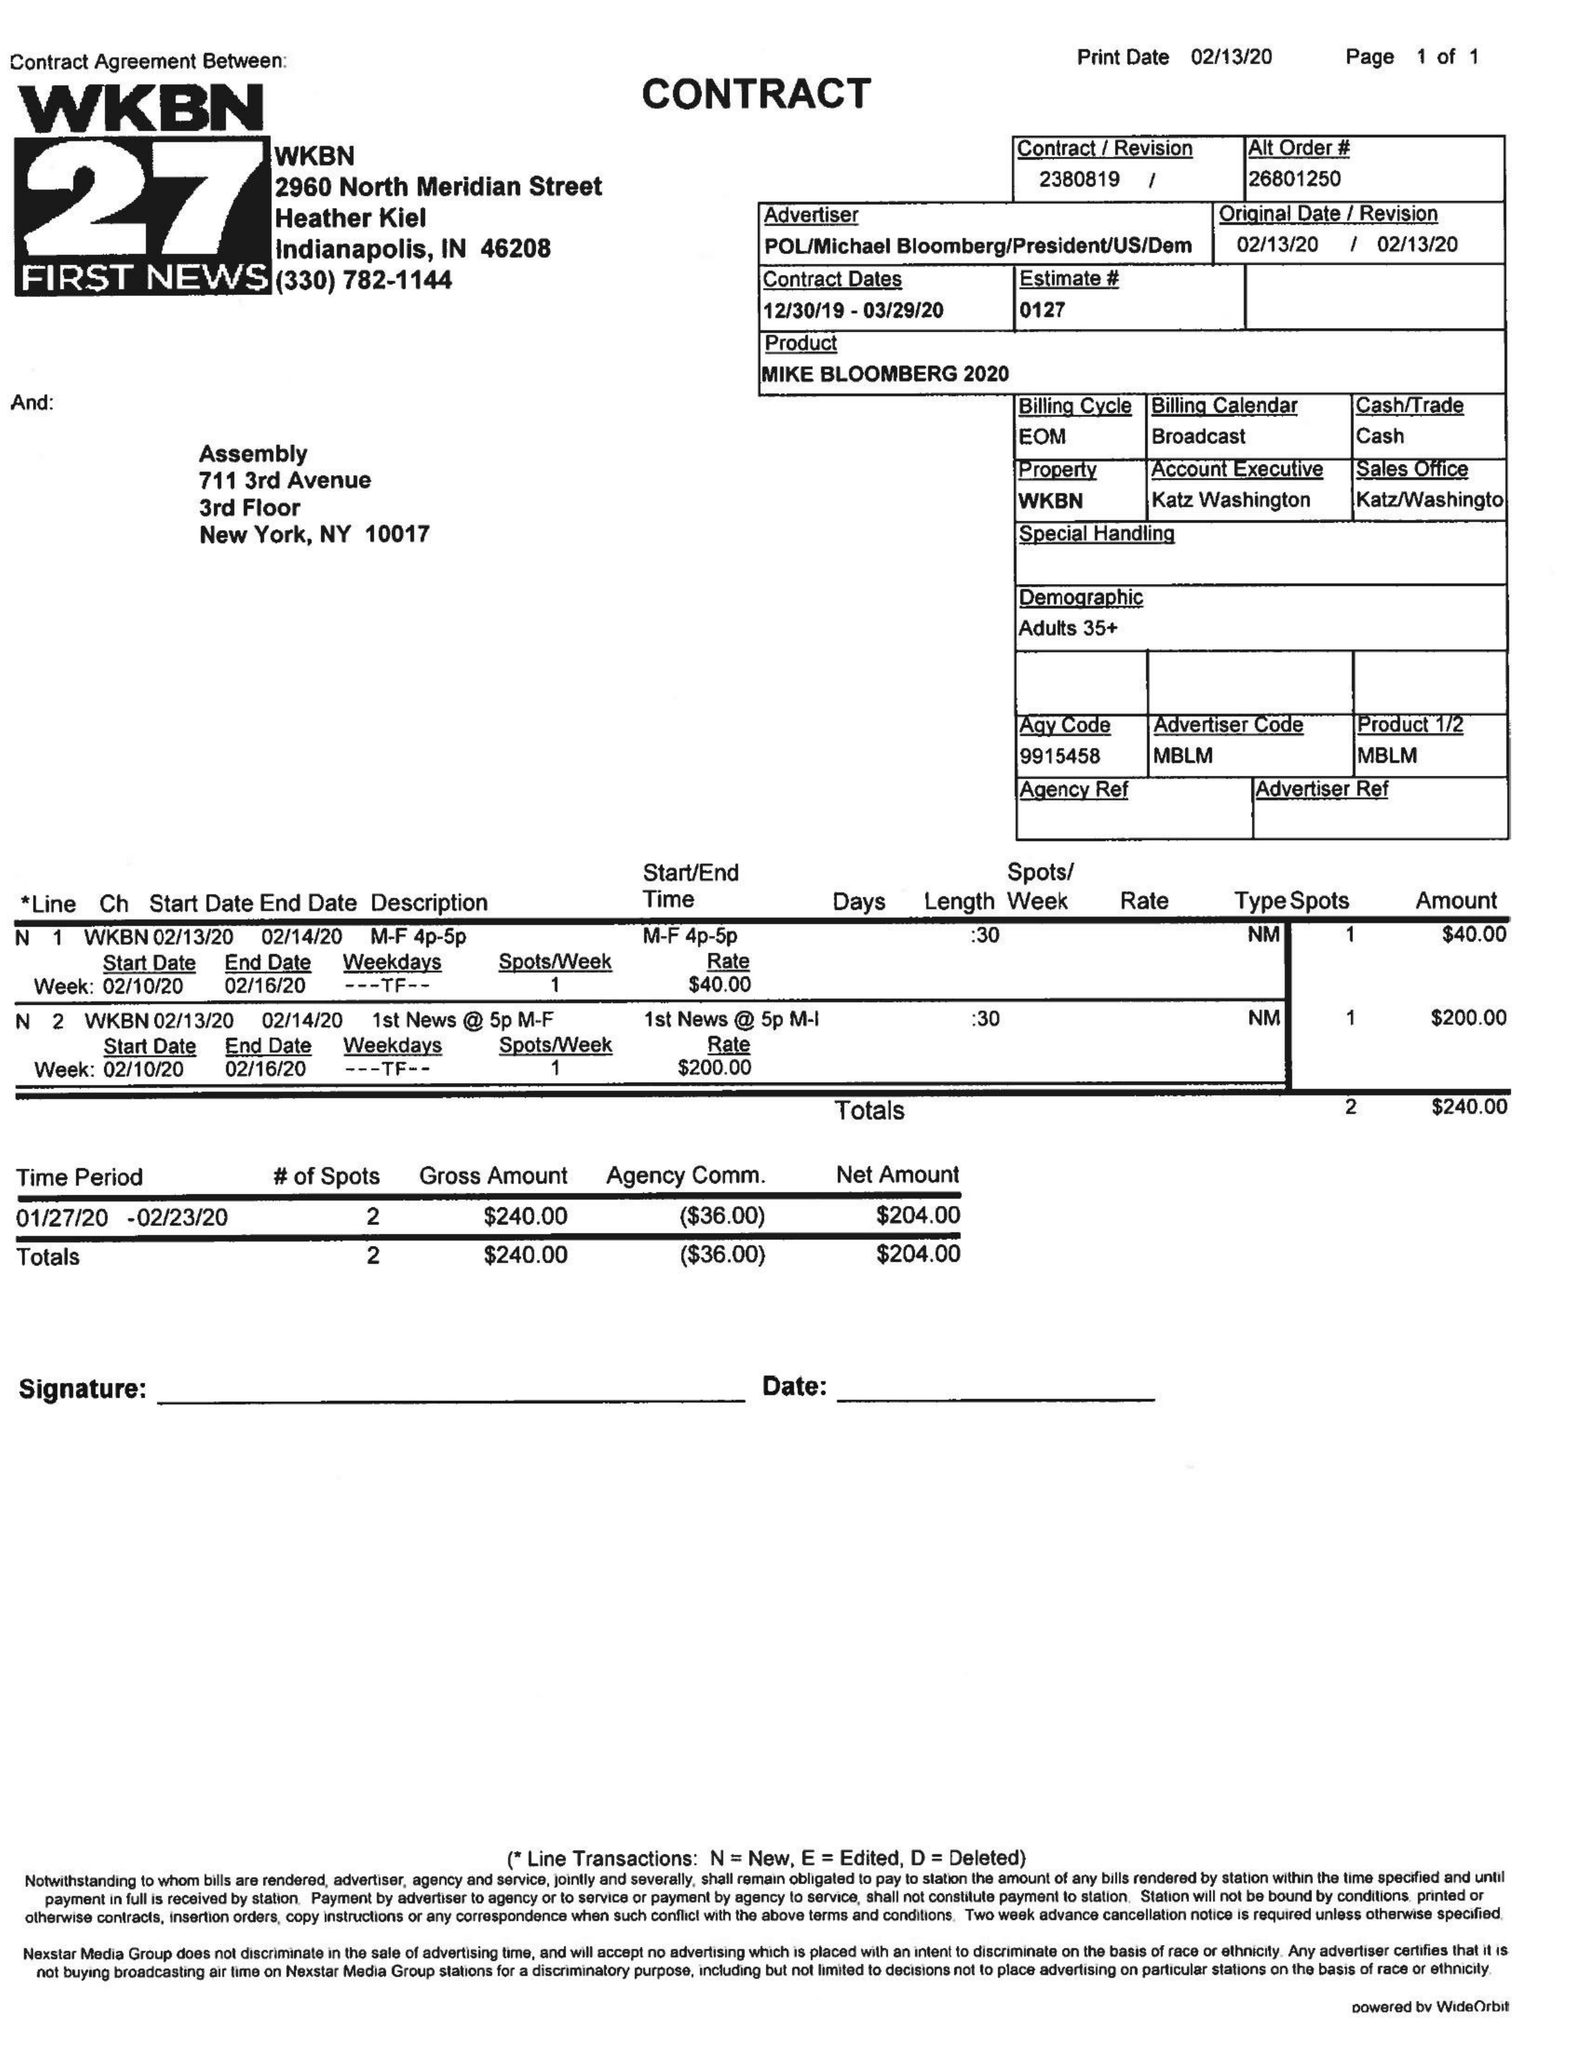What is the value for the advertiser?
Answer the question using a single word or phrase. POL/MICHAELBLOOMBERG/PRESIDENTUS/DEM 